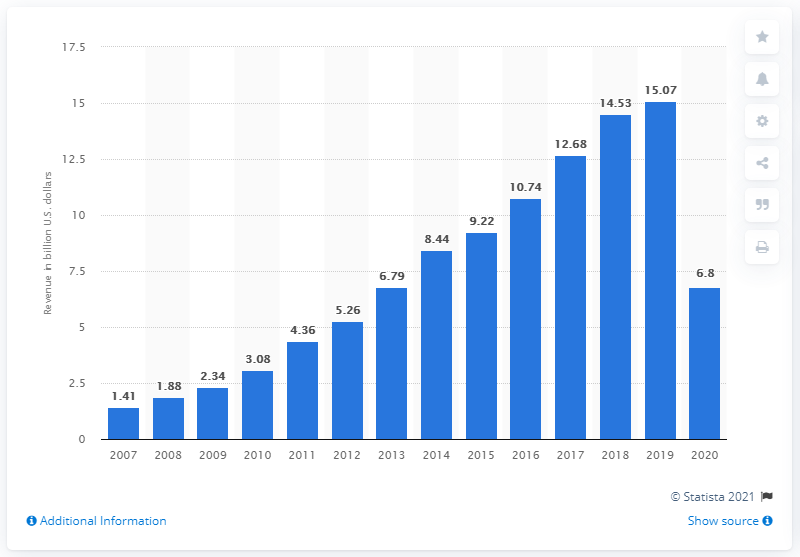Highlight a few significant elements in this photo. The total income of Booking Holdings in 2019 was $15.07 billion. In 2020, the revenue of Booking Holdings, a worldwide firm, was approximately 6.8 billion US dollars. 